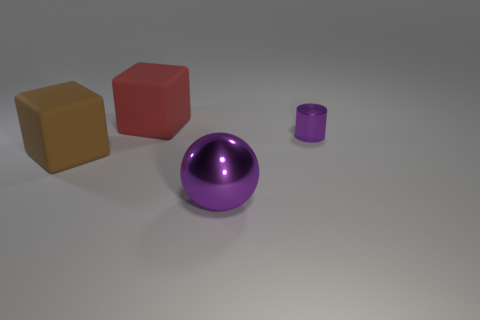Add 2 large rubber objects. How many objects exist? 6 Subtract 1 spheres. How many spheres are left? 0 Subtract all purple cubes. Subtract all brown balls. How many cubes are left? 2 Subtract all gray cylinders. How many brown spheres are left? 0 Subtract all small purple cylinders. Subtract all cubes. How many objects are left? 1 Add 2 brown cubes. How many brown cubes are left? 3 Add 1 large metallic balls. How many large metallic balls exist? 2 Subtract 0 red balls. How many objects are left? 4 Subtract all cylinders. How many objects are left? 3 